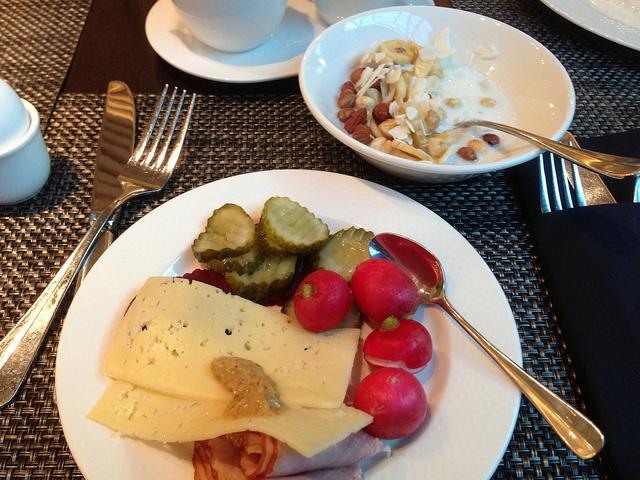What is the green stuff called on the plate?

Choices:
A) pea
B) corn
C) pickle
D) spinach pickle 